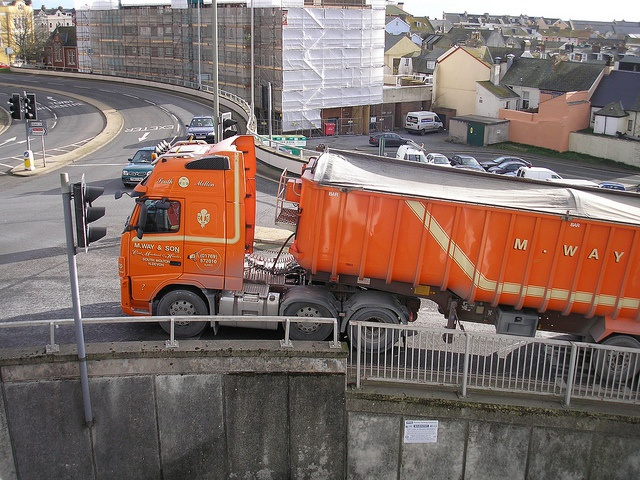Describe the objects in this image and their specific colors. I can see truck in tan, red, black, brown, and gray tones, traffic light in tan, black, gray, and darkgray tones, car in tan, gray, darkgray, and black tones, car in tan, gray, darkgray, and lavender tones, and car in tan, lightgray, darkgray, gray, and black tones in this image. 